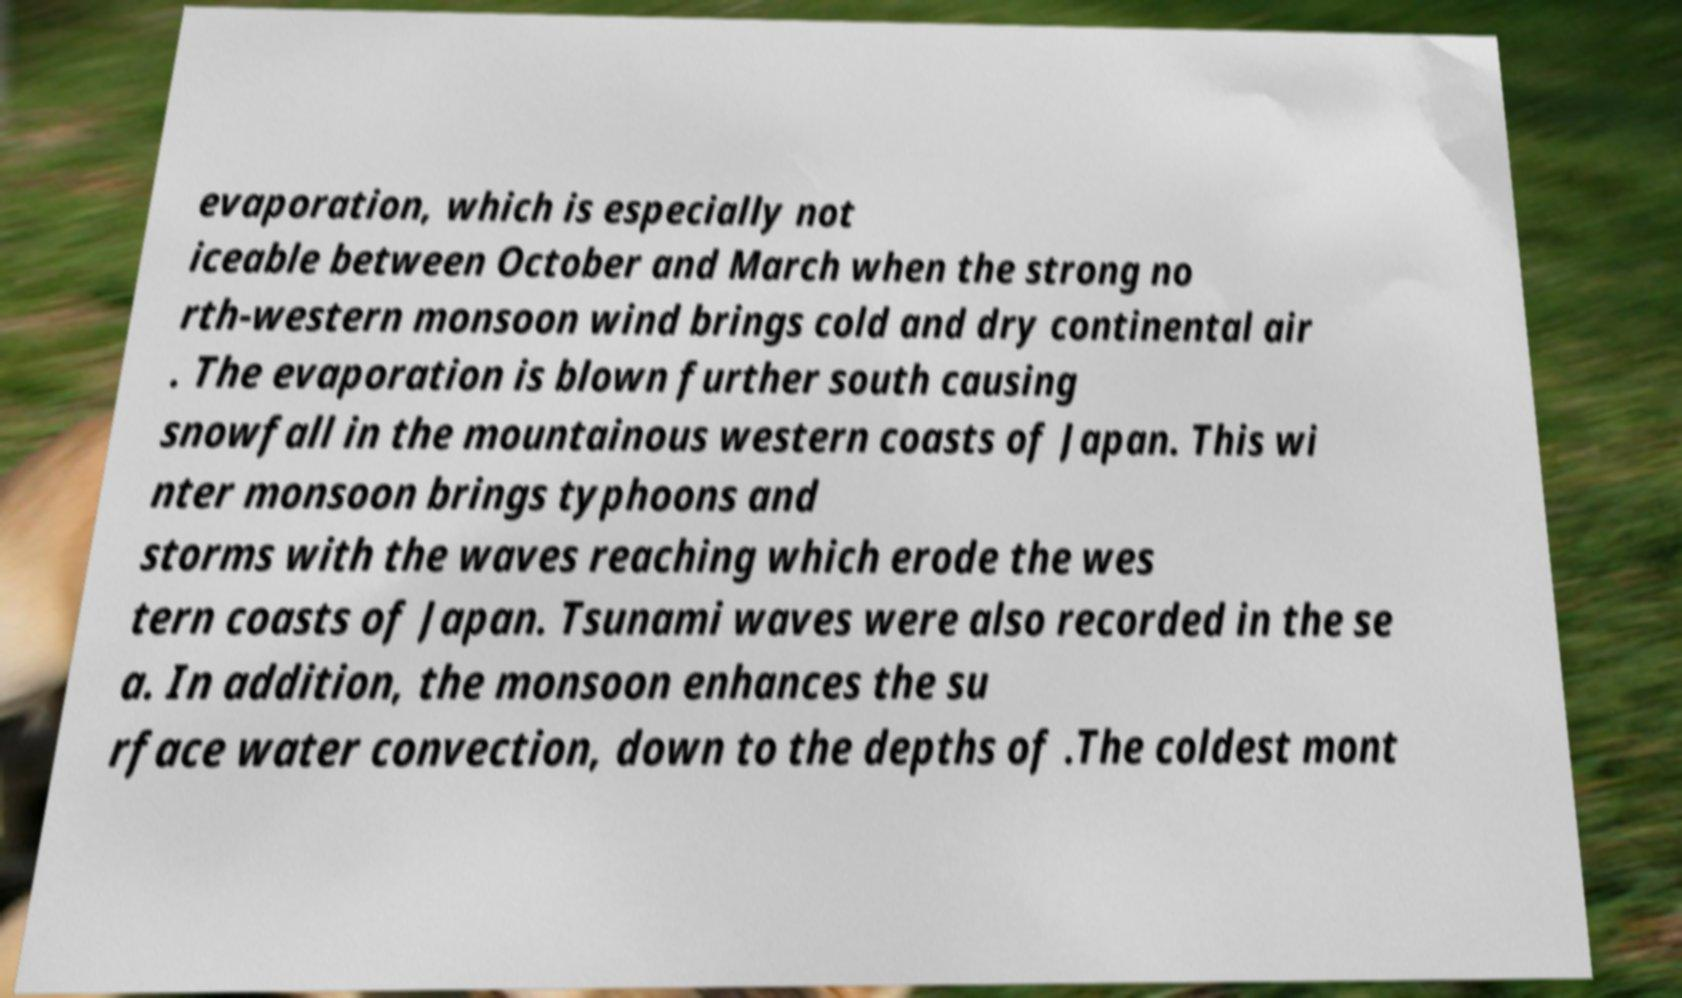Could you extract and type out the text from this image? evaporation, which is especially not iceable between October and March when the strong no rth-western monsoon wind brings cold and dry continental air . The evaporation is blown further south causing snowfall in the mountainous western coasts of Japan. This wi nter monsoon brings typhoons and storms with the waves reaching which erode the wes tern coasts of Japan. Tsunami waves were also recorded in the se a. In addition, the monsoon enhances the su rface water convection, down to the depths of .The coldest mont 